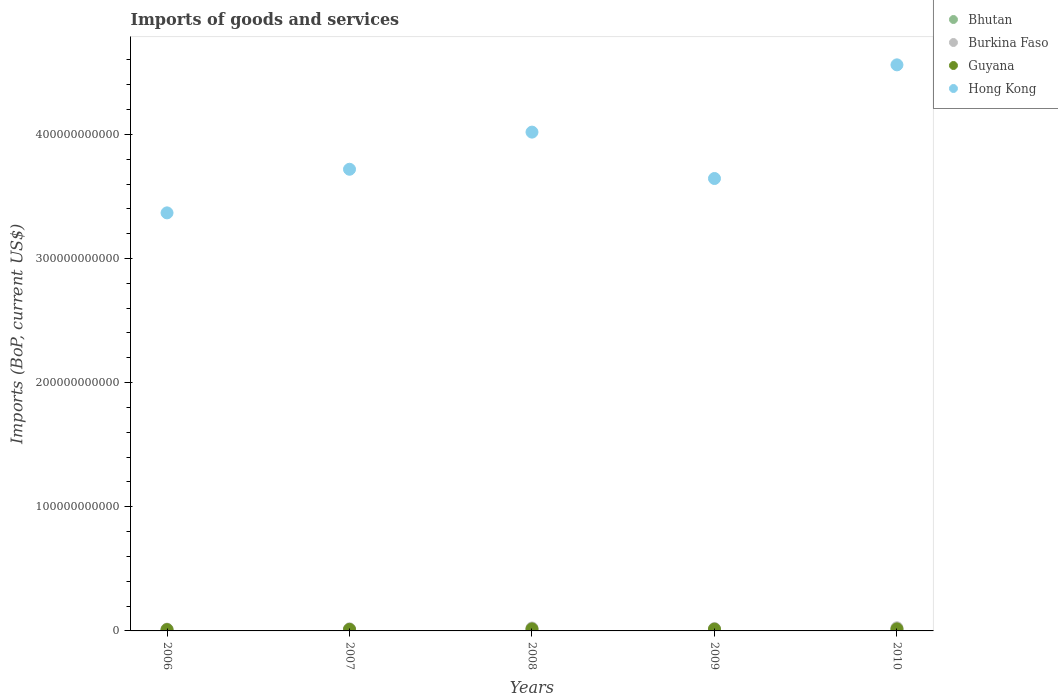How many different coloured dotlines are there?
Give a very brief answer. 4. Is the number of dotlines equal to the number of legend labels?
Offer a terse response. Yes. What is the amount spent on imports in Burkina Faso in 2007?
Provide a succinct answer. 1.70e+09. Across all years, what is the maximum amount spent on imports in Hong Kong?
Make the answer very short. 4.56e+11. Across all years, what is the minimum amount spent on imports in Hong Kong?
Your answer should be compact. 3.37e+11. What is the total amount spent on imports in Burkina Faso in the graph?
Your answer should be compact. 1.00e+1. What is the difference between the amount spent on imports in Bhutan in 2007 and that in 2008?
Give a very brief answer. -1.79e+08. What is the difference between the amount spent on imports in Hong Kong in 2006 and the amount spent on imports in Burkina Faso in 2008?
Offer a terse response. 3.34e+11. What is the average amount spent on imports in Hong Kong per year?
Make the answer very short. 3.86e+11. In the year 2009, what is the difference between the amount spent on imports in Guyana and amount spent on imports in Burkina Faso?
Provide a short and direct response. -4.90e+08. What is the ratio of the amount spent on imports in Guyana in 2006 to that in 2010?
Make the answer very short. 0.64. Is the difference between the amount spent on imports in Guyana in 2006 and 2008 greater than the difference between the amount spent on imports in Burkina Faso in 2006 and 2008?
Your answer should be very brief. Yes. What is the difference between the highest and the second highest amount spent on imports in Guyana?
Provide a short and direct response. 8.76e+06. What is the difference between the highest and the lowest amount spent on imports in Hong Kong?
Keep it short and to the point. 1.19e+11. Is the sum of the amount spent on imports in Burkina Faso in 2006 and 2009 greater than the maximum amount spent on imports in Bhutan across all years?
Your answer should be compact. Yes. Is it the case that in every year, the sum of the amount spent on imports in Bhutan and amount spent on imports in Guyana  is greater than the sum of amount spent on imports in Hong Kong and amount spent on imports in Burkina Faso?
Your response must be concise. No. Is it the case that in every year, the sum of the amount spent on imports in Guyana and amount spent on imports in Hong Kong  is greater than the amount spent on imports in Burkina Faso?
Provide a succinct answer. Yes. Is the amount spent on imports in Burkina Faso strictly greater than the amount spent on imports in Bhutan over the years?
Provide a succinct answer. Yes. Is the amount spent on imports in Bhutan strictly less than the amount spent on imports in Burkina Faso over the years?
Keep it short and to the point. Yes. What is the difference between two consecutive major ticks on the Y-axis?
Ensure brevity in your answer.  1.00e+11. Are the values on the major ticks of Y-axis written in scientific E-notation?
Give a very brief answer. No. Does the graph contain any zero values?
Ensure brevity in your answer.  No. Where does the legend appear in the graph?
Your answer should be very brief. Top right. What is the title of the graph?
Provide a succinct answer. Imports of goods and services. What is the label or title of the X-axis?
Offer a terse response. Years. What is the label or title of the Y-axis?
Your answer should be very brief. Imports (BoP, current US$). What is the Imports (BoP, current US$) in Bhutan in 2006?
Ensure brevity in your answer.  4.99e+08. What is the Imports (BoP, current US$) in Burkina Faso in 2006?
Give a very brief answer. 1.45e+09. What is the Imports (BoP, current US$) in Guyana in 2006?
Make the answer very short. 1.06e+09. What is the Imports (BoP, current US$) in Hong Kong in 2006?
Make the answer very short. 3.37e+11. What is the Imports (BoP, current US$) of Bhutan in 2007?
Your response must be concise. 5.86e+08. What is the Imports (BoP, current US$) of Burkina Faso in 2007?
Make the answer very short. 1.70e+09. What is the Imports (BoP, current US$) in Guyana in 2007?
Make the answer very short. 1.26e+09. What is the Imports (BoP, current US$) in Hong Kong in 2007?
Your answer should be very brief. 3.72e+11. What is the Imports (BoP, current US$) in Bhutan in 2008?
Your answer should be very brief. 7.66e+08. What is the Imports (BoP, current US$) of Burkina Faso in 2008?
Give a very brief answer. 2.35e+09. What is the Imports (BoP, current US$) in Guyana in 2008?
Your response must be concise. 1.65e+09. What is the Imports (BoP, current US$) of Hong Kong in 2008?
Make the answer very short. 4.02e+11. What is the Imports (BoP, current US$) in Bhutan in 2009?
Provide a short and direct response. 6.82e+08. What is the Imports (BoP, current US$) of Burkina Faso in 2009?
Provide a short and direct response. 1.94e+09. What is the Imports (BoP, current US$) of Guyana in 2009?
Offer a terse response. 1.45e+09. What is the Imports (BoP, current US$) of Hong Kong in 2009?
Make the answer very short. 3.64e+11. What is the Imports (BoP, current US$) in Bhutan in 2010?
Ensure brevity in your answer.  9.35e+08. What is the Imports (BoP, current US$) of Burkina Faso in 2010?
Make the answer very short. 2.56e+09. What is the Imports (BoP, current US$) of Guyana in 2010?
Give a very brief answer. 1.66e+09. What is the Imports (BoP, current US$) in Hong Kong in 2010?
Your answer should be very brief. 4.56e+11. Across all years, what is the maximum Imports (BoP, current US$) of Bhutan?
Offer a terse response. 9.35e+08. Across all years, what is the maximum Imports (BoP, current US$) of Burkina Faso?
Give a very brief answer. 2.56e+09. Across all years, what is the maximum Imports (BoP, current US$) in Guyana?
Offer a very short reply. 1.66e+09. Across all years, what is the maximum Imports (BoP, current US$) in Hong Kong?
Make the answer very short. 4.56e+11. Across all years, what is the minimum Imports (BoP, current US$) of Bhutan?
Provide a succinct answer. 4.99e+08. Across all years, what is the minimum Imports (BoP, current US$) in Burkina Faso?
Provide a succinct answer. 1.45e+09. Across all years, what is the minimum Imports (BoP, current US$) in Guyana?
Your answer should be very brief. 1.06e+09. Across all years, what is the minimum Imports (BoP, current US$) in Hong Kong?
Your answer should be compact. 3.37e+11. What is the total Imports (BoP, current US$) of Bhutan in the graph?
Provide a short and direct response. 3.47e+09. What is the total Imports (BoP, current US$) of Burkina Faso in the graph?
Ensure brevity in your answer.  1.00e+1. What is the total Imports (BoP, current US$) in Guyana in the graph?
Offer a terse response. 7.07e+09. What is the total Imports (BoP, current US$) in Hong Kong in the graph?
Ensure brevity in your answer.  1.93e+12. What is the difference between the Imports (BoP, current US$) in Bhutan in 2006 and that in 2007?
Provide a succinct answer. -8.69e+07. What is the difference between the Imports (BoP, current US$) of Burkina Faso in 2006 and that in 2007?
Keep it short and to the point. -2.51e+08. What is the difference between the Imports (BoP, current US$) in Guyana in 2006 and that in 2007?
Make the answer very short. -2.00e+08. What is the difference between the Imports (BoP, current US$) of Hong Kong in 2006 and that in 2007?
Your answer should be compact. -3.51e+1. What is the difference between the Imports (BoP, current US$) in Bhutan in 2006 and that in 2008?
Give a very brief answer. -2.66e+08. What is the difference between the Imports (BoP, current US$) of Burkina Faso in 2006 and that in 2008?
Make the answer very short. -9.02e+08. What is the difference between the Imports (BoP, current US$) of Guyana in 2006 and that in 2008?
Give a very brief answer. -5.94e+08. What is the difference between the Imports (BoP, current US$) of Hong Kong in 2006 and that in 2008?
Make the answer very short. -6.50e+1. What is the difference between the Imports (BoP, current US$) of Bhutan in 2006 and that in 2009?
Offer a terse response. -1.83e+08. What is the difference between the Imports (BoP, current US$) in Burkina Faso in 2006 and that in 2009?
Provide a short and direct response. -4.91e+08. What is the difference between the Imports (BoP, current US$) in Guyana in 2006 and that in 2009?
Provide a short and direct response. -3.97e+08. What is the difference between the Imports (BoP, current US$) of Hong Kong in 2006 and that in 2009?
Ensure brevity in your answer.  -2.77e+1. What is the difference between the Imports (BoP, current US$) in Bhutan in 2006 and that in 2010?
Keep it short and to the point. -4.36e+08. What is the difference between the Imports (BoP, current US$) in Burkina Faso in 2006 and that in 2010?
Your answer should be compact. -1.11e+09. What is the difference between the Imports (BoP, current US$) of Guyana in 2006 and that in 2010?
Provide a succinct answer. -6.02e+08. What is the difference between the Imports (BoP, current US$) in Hong Kong in 2006 and that in 2010?
Ensure brevity in your answer.  -1.19e+11. What is the difference between the Imports (BoP, current US$) of Bhutan in 2007 and that in 2008?
Make the answer very short. -1.79e+08. What is the difference between the Imports (BoP, current US$) of Burkina Faso in 2007 and that in 2008?
Ensure brevity in your answer.  -6.51e+08. What is the difference between the Imports (BoP, current US$) of Guyana in 2007 and that in 2008?
Your response must be concise. -3.93e+08. What is the difference between the Imports (BoP, current US$) in Hong Kong in 2007 and that in 2008?
Provide a succinct answer. -2.99e+1. What is the difference between the Imports (BoP, current US$) in Bhutan in 2007 and that in 2009?
Provide a succinct answer. -9.58e+07. What is the difference between the Imports (BoP, current US$) in Burkina Faso in 2007 and that in 2009?
Ensure brevity in your answer.  -2.40e+08. What is the difference between the Imports (BoP, current US$) of Guyana in 2007 and that in 2009?
Make the answer very short. -1.96e+08. What is the difference between the Imports (BoP, current US$) of Hong Kong in 2007 and that in 2009?
Keep it short and to the point. 7.44e+09. What is the difference between the Imports (BoP, current US$) of Bhutan in 2007 and that in 2010?
Keep it short and to the point. -3.49e+08. What is the difference between the Imports (BoP, current US$) of Burkina Faso in 2007 and that in 2010?
Offer a terse response. -8.55e+08. What is the difference between the Imports (BoP, current US$) in Guyana in 2007 and that in 2010?
Provide a short and direct response. -4.02e+08. What is the difference between the Imports (BoP, current US$) in Hong Kong in 2007 and that in 2010?
Offer a very short reply. -8.41e+1. What is the difference between the Imports (BoP, current US$) in Bhutan in 2008 and that in 2009?
Make the answer very short. 8.35e+07. What is the difference between the Imports (BoP, current US$) in Burkina Faso in 2008 and that in 2009?
Your answer should be very brief. 4.11e+08. What is the difference between the Imports (BoP, current US$) of Guyana in 2008 and that in 2009?
Make the answer very short. 1.97e+08. What is the difference between the Imports (BoP, current US$) in Hong Kong in 2008 and that in 2009?
Offer a terse response. 3.74e+1. What is the difference between the Imports (BoP, current US$) in Bhutan in 2008 and that in 2010?
Provide a short and direct response. -1.70e+08. What is the difference between the Imports (BoP, current US$) in Burkina Faso in 2008 and that in 2010?
Provide a succinct answer. -2.04e+08. What is the difference between the Imports (BoP, current US$) in Guyana in 2008 and that in 2010?
Provide a succinct answer. -8.76e+06. What is the difference between the Imports (BoP, current US$) in Hong Kong in 2008 and that in 2010?
Your response must be concise. -5.42e+1. What is the difference between the Imports (BoP, current US$) of Bhutan in 2009 and that in 2010?
Your answer should be very brief. -2.53e+08. What is the difference between the Imports (BoP, current US$) of Burkina Faso in 2009 and that in 2010?
Make the answer very short. -6.15e+08. What is the difference between the Imports (BoP, current US$) in Guyana in 2009 and that in 2010?
Offer a very short reply. -2.06e+08. What is the difference between the Imports (BoP, current US$) of Hong Kong in 2009 and that in 2010?
Ensure brevity in your answer.  -9.16e+1. What is the difference between the Imports (BoP, current US$) of Bhutan in 2006 and the Imports (BoP, current US$) of Burkina Faso in 2007?
Your answer should be compact. -1.20e+09. What is the difference between the Imports (BoP, current US$) in Bhutan in 2006 and the Imports (BoP, current US$) in Guyana in 2007?
Ensure brevity in your answer.  -7.56e+08. What is the difference between the Imports (BoP, current US$) of Bhutan in 2006 and the Imports (BoP, current US$) of Hong Kong in 2007?
Your answer should be very brief. -3.71e+11. What is the difference between the Imports (BoP, current US$) in Burkina Faso in 2006 and the Imports (BoP, current US$) in Guyana in 2007?
Keep it short and to the point. 1.95e+08. What is the difference between the Imports (BoP, current US$) of Burkina Faso in 2006 and the Imports (BoP, current US$) of Hong Kong in 2007?
Ensure brevity in your answer.  -3.70e+11. What is the difference between the Imports (BoP, current US$) of Guyana in 2006 and the Imports (BoP, current US$) of Hong Kong in 2007?
Provide a succinct answer. -3.71e+11. What is the difference between the Imports (BoP, current US$) in Bhutan in 2006 and the Imports (BoP, current US$) in Burkina Faso in 2008?
Your answer should be compact. -1.85e+09. What is the difference between the Imports (BoP, current US$) in Bhutan in 2006 and the Imports (BoP, current US$) in Guyana in 2008?
Provide a short and direct response. -1.15e+09. What is the difference between the Imports (BoP, current US$) of Bhutan in 2006 and the Imports (BoP, current US$) of Hong Kong in 2008?
Give a very brief answer. -4.01e+11. What is the difference between the Imports (BoP, current US$) in Burkina Faso in 2006 and the Imports (BoP, current US$) in Guyana in 2008?
Offer a very short reply. -1.98e+08. What is the difference between the Imports (BoP, current US$) of Burkina Faso in 2006 and the Imports (BoP, current US$) of Hong Kong in 2008?
Your answer should be compact. -4.00e+11. What is the difference between the Imports (BoP, current US$) in Guyana in 2006 and the Imports (BoP, current US$) in Hong Kong in 2008?
Provide a succinct answer. -4.01e+11. What is the difference between the Imports (BoP, current US$) of Bhutan in 2006 and the Imports (BoP, current US$) of Burkina Faso in 2009?
Give a very brief answer. -1.44e+09. What is the difference between the Imports (BoP, current US$) of Bhutan in 2006 and the Imports (BoP, current US$) of Guyana in 2009?
Ensure brevity in your answer.  -9.52e+08. What is the difference between the Imports (BoP, current US$) of Bhutan in 2006 and the Imports (BoP, current US$) of Hong Kong in 2009?
Offer a terse response. -3.64e+11. What is the difference between the Imports (BoP, current US$) of Burkina Faso in 2006 and the Imports (BoP, current US$) of Guyana in 2009?
Your response must be concise. -1.29e+06. What is the difference between the Imports (BoP, current US$) of Burkina Faso in 2006 and the Imports (BoP, current US$) of Hong Kong in 2009?
Your response must be concise. -3.63e+11. What is the difference between the Imports (BoP, current US$) of Guyana in 2006 and the Imports (BoP, current US$) of Hong Kong in 2009?
Give a very brief answer. -3.63e+11. What is the difference between the Imports (BoP, current US$) of Bhutan in 2006 and the Imports (BoP, current US$) of Burkina Faso in 2010?
Your answer should be compact. -2.06e+09. What is the difference between the Imports (BoP, current US$) of Bhutan in 2006 and the Imports (BoP, current US$) of Guyana in 2010?
Provide a succinct answer. -1.16e+09. What is the difference between the Imports (BoP, current US$) of Bhutan in 2006 and the Imports (BoP, current US$) of Hong Kong in 2010?
Your response must be concise. -4.56e+11. What is the difference between the Imports (BoP, current US$) of Burkina Faso in 2006 and the Imports (BoP, current US$) of Guyana in 2010?
Provide a short and direct response. -2.07e+08. What is the difference between the Imports (BoP, current US$) in Burkina Faso in 2006 and the Imports (BoP, current US$) in Hong Kong in 2010?
Provide a succinct answer. -4.55e+11. What is the difference between the Imports (BoP, current US$) in Guyana in 2006 and the Imports (BoP, current US$) in Hong Kong in 2010?
Give a very brief answer. -4.55e+11. What is the difference between the Imports (BoP, current US$) in Bhutan in 2007 and the Imports (BoP, current US$) in Burkina Faso in 2008?
Your answer should be very brief. -1.77e+09. What is the difference between the Imports (BoP, current US$) of Bhutan in 2007 and the Imports (BoP, current US$) of Guyana in 2008?
Your response must be concise. -1.06e+09. What is the difference between the Imports (BoP, current US$) in Bhutan in 2007 and the Imports (BoP, current US$) in Hong Kong in 2008?
Provide a short and direct response. -4.01e+11. What is the difference between the Imports (BoP, current US$) in Burkina Faso in 2007 and the Imports (BoP, current US$) in Guyana in 2008?
Ensure brevity in your answer.  5.27e+07. What is the difference between the Imports (BoP, current US$) of Burkina Faso in 2007 and the Imports (BoP, current US$) of Hong Kong in 2008?
Your response must be concise. -4.00e+11. What is the difference between the Imports (BoP, current US$) of Guyana in 2007 and the Imports (BoP, current US$) of Hong Kong in 2008?
Your answer should be compact. -4.01e+11. What is the difference between the Imports (BoP, current US$) of Bhutan in 2007 and the Imports (BoP, current US$) of Burkina Faso in 2009?
Keep it short and to the point. -1.36e+09. What is the difference between the Imports (BoP, current US$) in Bhutan in 2007 and the Imports (BoP, current US$) in Guyana in 2009?
Your response must be concise. -8.65e+08. What is the difference between the Imports (BoP, current US$) in Bhutan in 2007 and the Imports (BoP, current US$) in Hong Kong in 2009?
Your answer should be compact. -3.64e+11. What is the difference between the Imports (BoP, current US$) in Burkina Faso in 2007 and the Imports (BoP, current US$) in Guyana in 2009?
Provide a short and direct response. 2.50e+08. What is the difference between the Imports (BoP, current US$) of Burkina Faso in 2007 and the Imports (BoP, current US$) of Hong Kong in 2009?
Keep it short and to the point. -3.63e+11. What is the difference between the Imports (BoP, current US$) in Guyana in 2007 and the Imports (BoP, current US$) in Hong Kong in 2009?
Provide a short and direct response. -3.63e+11. What is the difference between the Imports (BoP, current US$) of Bhutan in 2007 and the Imports (BoP, current US$) of Burkina Faso in 2010?
Offer a very short reply. -1.97e+09. What is the difference between the Imports (BoP, current US$) in Bhutan in 2007 and the Imports (BoP, current US$) in Guyana in 2010?
Make the answer very short. -1.07e+09. What is the difference between the Imports (BoP, current US$) in Bhutan in 2007 and the Imports (BoP, current US$) in Hong Kong in 2010?
Give a very brief answer. -4.55e+11. What is the difference between the Imports (BoP, current US$) of Burkina Faso in 2007 and the Imports (BoP, current US$) of Guyana in 2010?
Your answer should be compact. 4.39e+07. What is the difference between the Imports (BoP, current US$) in Burkina Faso in 2007 and the Imports (BoP, current US$) in Hong Kong in 2010?
Your answer should be very brief. -4.54e+11. What is the difference between the Imports (BoP, current US$) in Guyana in 2007 and the Imports (BoP, current US$) in Hong Kong in 2010?
Provide a short and direct response. -4.55e+11. What is the difference between the Imports (BoP, current US$) of Bhutan in 2008 and the Imports (BoP, current US$) of Burkina Faso in 2009?
Your response must be concise. -1.18e+09. What is the difference between the Imports (BoP, current US$) in Bhutan in 2008 and the Imports (BoP, current US$) in Guyana in 2009?
Your response must be concise. -6.86e+08. What is the difference between the Imports (BoP, current US$) of Bhutan in 2008 and the Imports (BoP, current US$) of Hong Kong in 2009?
Ensure brevity in your answer.  -3.64e+11. What is the difference between the Imports (BoP, current US$) of Burkina Faso in 2008 and the Imports (BoP, current US$) of Guyana in 2009?
Give a very brief answer. 9.01e+08. What is the difference between the Imports (BoP, current US$) of Burkina Faso in 2008 and the Imports (BoP, current US$) of Hong Kong in 2009?
Your answer should be very brief. -3.62e+11. What is the difference between the Imports (BoP, current US$) in Guyana in 2008 and the Imports (BoP, current US$) in Hong Kong in 2009?
Give a very brief answer. -3.63e+11. What is the difference between the Imports (BoP, current US$) in Bhutan in 2008 and the Imports (BoP, current US$) in Burkina Faso in 2010?
Your answer should be compact. -1.79e+09. What is the difference between the Imports (BoP, current US$) of Bhutan in 2008 and the Imports (BoP, current US$) of Guyana in 2010?
Provide a succinct answer. -8.92e+08. What is the difference between the Imports (BoP, current US$) of Bhutan in 2008 and the Imports (BoP, current US$) of Hong Kong in 2010?
Offer a terse response. -4.55e+11. What is the difference between the Imports (BoP, current US$) in Burkina Faso in 2008 and the Imports (BoP, current US$) in Guyana in 2010?
Provide a short and direct response. 6.95e+08. What is the difference between the Imports (BoP, current US$) in Burkina Faso in 2008 and the Imports (BoP, current US$) in Hong Kong in 2010?
Give a very brief answer. -4.54e+11. What is the difference between the Imports (BoP, current US$) of Guyana in 2008 and the Imports (BoP, current US$) of Hong Kong in 2010?
Offer a terse response. -4.54e+11. What is the difference between the Imports (BoP, current US$) in Bhutan in 2009 and the Imports (BoP, current US$) in Burkina Faso in 2010?
Provide a succinct answer. -1.87e+09. What is the difference between the Imports (BoP, current US$) in Bhutan in 2009 and the Imports (BoP, current US$) in Guyana in 2010?
Your answer should be very brief. -9.75e+08. What is the difference between the Imports (BoP, current US$) in Bhutan in 2009 and the Imports (BoP, current US$) in Hong Kong in 2010?
Offer a terse response. -4.55e+11. What is the difference between the Imports (BoP, current US$) in Burkina Faso in 2009 and the Imports (BoP, current US$) in Guyana in 2010?
Ensure brevity in your answer.  2.84e+08. What is the difference between the Imports (BoP, current US$) in Burkina Faso in 2009 and the Imports (BoP, current US$) in Hong Kong in 2010?
Keep it short and to the point. -4.54e+11. What is the difference between the Imports (BoP, current US$) of Guyana in 2009 and the Imports (BoP, current US$) of Hong Kong in 2010?
Make the answer very short. -4.55e+11. What is the average Imports (BoP, current US$) of Bhutan per year?
Keep it short and to the point. 6.94e+08. What is the average Imports (BoP, current US$) in Burkina Faso per year?
Your answer should be very brief. 2.00e+09. What is the average Imports (BoP, current US$) of Guyana per year?
Give a very brief answer. 1.41e+09. What is the average Imports (BoP, current US$) in Hong Kong per year?
Provide a succinct answer. 3.86e+11. In the year 2006, what is the difference between the Imports (BoP, current US$) in Bhutan and Imports (BoP, current US$) in Burkina Faso?
Offer a very short reply. -9.51e+08. In the year 2006, what is the difference between the Imports (BoP, current US$) of Bhutan and Imports (BoP, current US$) of Guyana?
Keep it short and to the point. -5.56e+08. In the year 2006, what is the difference between the Imports (BoP, current US$) in Bhutan and Imports (BoP, current US$) in Hong Kong?
Make the answer very short. -3.36e+11. In the year 2006, what is the difference between the Imports (BoP, current US$) of Burkina Faso and Imports (BoP, current US$) of Guyana?
Make the answer very short. 3.95e+08. In the year 2006, what is the difference between the Imports (BoP, current US$) of Burkina Faso and Imports (BoP, current US$) of Hong Kong?
Provide a succinct answer. -3.35e+11. In the year 2006, what is the difference between the Imports (BoP, current US$) of Guyana and Imports (BoP, current US$) of Hong Kong?
Offer a terse response. -3.36e+11. In the year 2007, what is the difference between the Imports (BoP, current US$) of Bhutan and Imports (BoP, current US$) of Burkina Faso?
Your answer should be compact. -1.12e+09. In the year 2007, what is the difference between the Imports (BoP, current US$) in Bhutan and Imports (BoP, current US$) in Guyana?
Your response must be concise. -6.69e+08. In the year 2007, what is the difference between the Imports (BoP, current US$) of Bhutan and Imports (BoP, current US$) of Hong Kong?
Give a very brief answer. -3.71e+11. In the year 2007, what is the difference between the Imports (BoP, current US$) in Burkina Faso and Imports (BoP, current US$) in Guyana?
Make the answer very short. 4.46e+08. In the year 2007, what is the difference between the Imports (BoP, current US$) of Burkina Faso and Imports (BoP, current US$) of Hong Kong?
Your answer should be very brief. -3.70e+11. In the year 2007, what is the difference between the Imports (BoP, current US$) in Guyana and Imports (BoP, current US$) in Hong Kong?
Your answer should be very brief. -3.71e+11. In the year 2008, what is the difference between the Imports (BoP, current US$) of Bhutan and Imports (BoP, current US$) of Burkina Faso?
Make the answer very short. -1.59e+09. In the year 2008, what is the difference between the Imports (BoP, current US$) in Bhutan and Imports (BoP, current US$) in Guyana?
Offer a very short reply. -8.83e+08. In the year 2008, what is the difference between the Imports (BoP, current US$) in Bhutan and Imports (BoP, current US$) in Hong Kong?
Ensure brevity in your answer.  -4.01e+11. In the year 2008, what is the difference between the Imports (BoP, current US$) in Burkina Faso and Imports (BoP, current US$) in Guyana?
Offer a very short reply. 7.04e+08. In the year 2008, what is the difference between the Imports (BoP, current US$) of Burkina Faso and Imports (BoP, current US$) of Hong Kong?
Offer a terse response. -3.99e+11. In the year 2008, what is the difference between the Imports (BoP, current US$) in Guyana and Imports (BoP, current US$) in Hong Kong?
Make the answer very short. -4.00e+11. In the year 2009, what is the difference between the Imports (BoP, current US$) of Bhutan and Imports (BoP, current US$) of Burkina Faso?
Your response must be concise. -1.26e+09. In the year 2009, what is the difference between the Imports (BoP, current US$) in Bhutan and Imports (BoP, current US$) in Guyana?
Offer a very short reply. -7.70e+08. In the year 2009, what is the difference between the Imports (BoP, current US$) of Bhutan and Imports (BoP, current US$) of Hong Kong?
Make the answer very short. -3.64e+11. In the year 2009, what is the difference between the Imports (BoP, current US$) of Burkina Faso and Imports (BoP, current US$) of Guyana?
Keep it short and to the point. 4.90e+08. In the year 2009, what is the difference between the Imports (BoP, current US$) of Burkina Faso and Imports (BoP, current US$) of Hong Kong?
Ensure brevity in your answer.  -3.63e+11. In the year 2009, what is the difference between the Imports (BoP, current US$) of Guyana and Imports (BoP, current US$) of Hong Kong?
Keep it short and to the point. -3.63e+11. In the year 2010, what is the difference between the Imports (BoP, current US$) of Bhutan and Imports (BoP, current US$) of Burkina Faso?
Ensure brevity in your answer.  -1.62e+09. In the year 2010, what is the difference between the Imports (BoP, current US$) in Bhutan and Imports (BoP, current US$) in Guyana?
Your answer should be very brief. -7.22e+08. In the year 2010, what is the difference between the Imports (BoP, current US$) in Bhutan and Imports (BoP, current US$) in Hong Kong?
Your answer should be compact. -4.55e+11. In the year 2010, what is the difference between the Imports (BoP, current US$) of Burkina Faso and Imports (BoP, current US$) of Guyana?
Keep it short and to the point. 8.99e+08. In the year 2010, what is the difference between the Imports (BoP, current US$) in Burkina Faso and Imports (BoP, current US$) in Hong Kong?
Your answer should be compact. -4.53e+11. In the year 2010, what is the difference between the Imports (BoP, current US$) of Guyana and Imports (BoP, current US$) of Hong Kong?
Provide a short and direct response. -4.54e+11. What is the ratio of the Imports (BoP, current US$) in Bhutan in 2006 to that in 2007?
Your answer should be very brief. 0.85. What is the ratio of the Imports (BoP, current US$) of Burkina Faso in 2006 to that in 2007?
Your answer should be very brief. 0.85. What is the ratio of the Imports (BoP, current US$) of Guyana in 2006 to that in 2007?
Make the answer very short. 0.84. What is the ratio of the Imports (BoP, current US$) of Hong Kong in 2006 to that in 2007?
Make the answer very short. 0.91. What is the ratio of the Imports (BoP, current US$) of Bhutan in 2006 to that in 2008?
Your answer should be compact. 0.65. What is the ratio of the Imports (BoP, current US$) of Burkina Faso in 2006 to that in 2008?
Your answer should be very brief. 0.62. What is the ratio of the Imports (BoP, current US$) of Guyana in 2006 to that in 2008?
Give a very brief answer. 0.64. What is the ratio of the Imports (BoP, current US$) in Hong Kong in 2006 to that in 2008?
Provide a succinct answer. 0.84. What is the ratio of the Imports (BoP, current US$) in Bhutan in 2006 to that in 2009?
Your answer should be compact. 0.73. What is the ratio of the Imports (BoP, current US$) in Burkina Faso in 2006 to that in 2009?
Offer a terse response. 0.75. What is the ratio of the Imports (BoP, current US$) in Guyana in 2006 to that in 2009?
Give a very brief answer. 0.73. What is the ratio of the Imports (BoP, current US$) of Hong Kong in 2006 to that in 2009?
Offer a terse response. 0.92. What is the ratio of the Imports (BoP, current US$) in Bhutan in 2006 to that in 2010?
Provide a short and direct response. 0.53. What is the ratio of the Imports (BoP, current US$) of Burkina Faso in 2006 to that in 2010?
Keep it short and to the point. 0.57. What is the ratio of the Imports (BoP, current US$) of Guyana in 2006 to that in 2010?
Make the answer very short. 0.64. What is the ratio of the Imports (BoP, current US$) of Hong Kong in 2006 to that in 2010?
Your answer should be compact. 0.74. What is the ratio of the Imports (BoP, current US$) in Bhutan in 2007 to that in 2008?
Your answer should be compact. 0.77. What is the ratio of the Imports (BoP, current US$) in Burkina Faso in 2007 to that in 2008?
Give a very brief answer. 0.72. What is the ratio of the Imports (BoP, current US$) of Guyana in 2007 to that in 2008?
Ensure brevity in your answer.  0.76. What is the ratio of the Imports (BoP, current US$) of Hong Kong in 2007 to that in 2008?
Your answer should be very brief. 0.93. What is the ratio of the Imports (BoP, current US$) in Bhutan in 2007 to that in 2009?
Ensure brevity in your answer.  0.86. What is the ratio of the Imports (BoP, current US$) of Burkina Faso in 2007 to that in 2009?
Your answer should be very brief. 0.88. What is the ratio of the Imports (BoP, current US$) of Guyana in 2007 to that in 2009?
Give a very brief answer. 0.86. What is the ratio of the Imports (BoP, current US$) of Hong Kong in 2007 to that in 2009?
Your response must be concise. 1.02. What is the ratio of the Imports (BoP, current US$) in Bhutan in 2007 to that in 2010?
Your response must be concise. 0.63. What is the ratio of the Imports (BoP, current US$) in Burkina Faso in 2007 to that in 2010?
Make the answer very short. 0.67. What is the ratio of the Imports (BoP, current US$) in Guyana in 2007 to that in 2010?
Provide a short and direct response. 0.76. What is the ratio of the Imports (BoP, current US$) of Hong Kong in 2007 to that in 2010?
Make the answer very short. 0.82. What is the ratio of the Imports (BoP, current US$) in Bhutan in 2008 to that in 2009?
Your answer should be compact. 1.12. What is the ratio of the Imports (BoP, current US$) in Burkina Faso in 2008 to that in 2009?
Make the answer very short. 1.21. What is the ratio of the Imports (BoP, current US$) in Guyana in 2008 to that in 2009?
Offer a terse response. 1.14. What is the ratio of the Imports (BoP, current US$) of Hong Kong in 2008 to that in 2009?
Ensure brevity in your answer.  1.1. What is the ratio of the Imports (BoP, current US$) of Bhutan in 2008 to that in 2010?
Your answer should be very brief. 0.82. What is the ratio of the Imports (BoP, current US$) in Burkina Faso in 2008 to that in 2010?
Provide a short and direct response. 0.92. What is the ratio of the Imports (BoP, current US$) in Guyana in 2008 to that in 2010?
Keep it short and to the point. 0.99. What is the ratio of the Imports (BoP, current US$) of Hong Kong in 2008 to that in 2010?
Your answer should be compact. 0.88. What is the ratio of the Imports (BoP, current US$) of Bhutan in 2009 to that in 2010?
Provide a succinct answer. 0.73. What is the ratio of the Imports (BoP, current US$) in Burkina Faso in 2009 to that in 2010?
Provide a short and direct response. 0.76. What is the ratio of the Imports (BoP, current US$) in Guyana in 2009 to that in 2010?
Offer a terse response. 0.88. What is the ratio of the Imports (BoP, current US$) in Hong Kong in 2009 to that in 2010?
Make the answer very short. 0.8. What is the difference between the highest and the second highest Imports (BoP, current US$) of Bhutan?
Make the answer very short. 1.70e+08. What is the difference between the highest and the second highest Imports (BoP, current US$) of Burkina Faso?
Keep it short and to the point. 2.04e+08. What is the difference between the highest and the second highest Imports (BoP, current US$) of Guyana?
Make the answer very short. 8.76e+06. What is the difference between the highest and the second highest Imports (BoP, current US$) in Hong Kong?
Your answer should be very brief. 5.42e+1. What is the difference between the highest and the lowest Imports (BoP, current US$) of Bhutan?
Ensure brevity in your answer.  4.36e+08. What is the difference between the highest and the lowest Imports (BoP, current US$) of Burkina Faso?
Offer a terse response. 1.11e+09. What is the difference between the highest and the lowest Imports (BoP, current US$) of Guyana?
Your answer should be compact. 6.02e+08. What is the difference between the highest and the lowest Imports (BoP, current US$) in Hong Kong?
Give a very brief answer. 1.19e+11. 